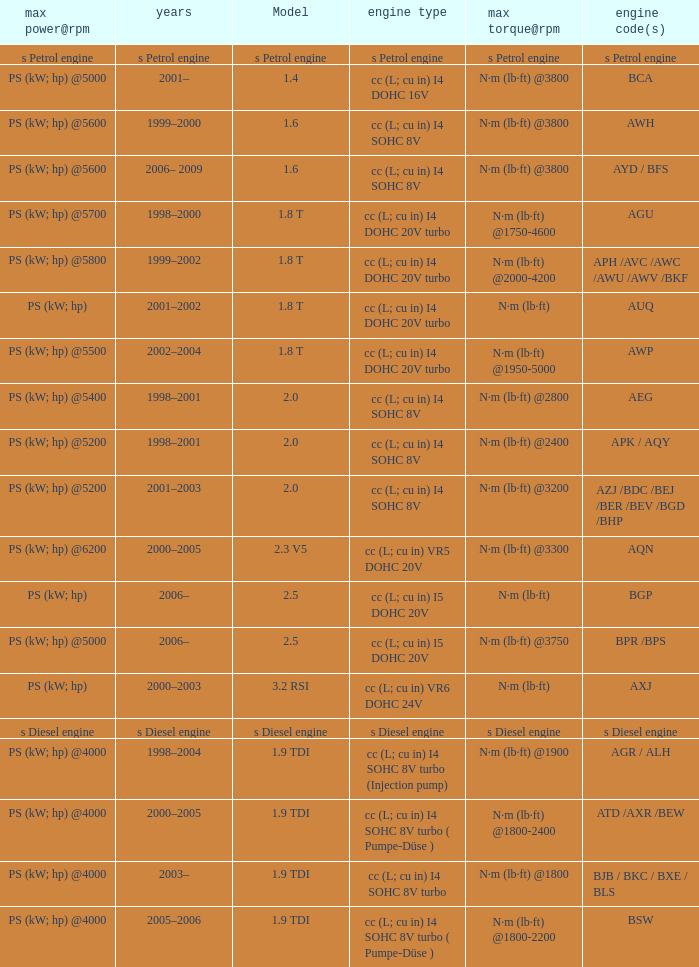What was the max torque@rpm of the engine which had the model 2.5  and a max power@rpm of ps (kw; hp) @5000? N·m (lb·ft) @3750. 